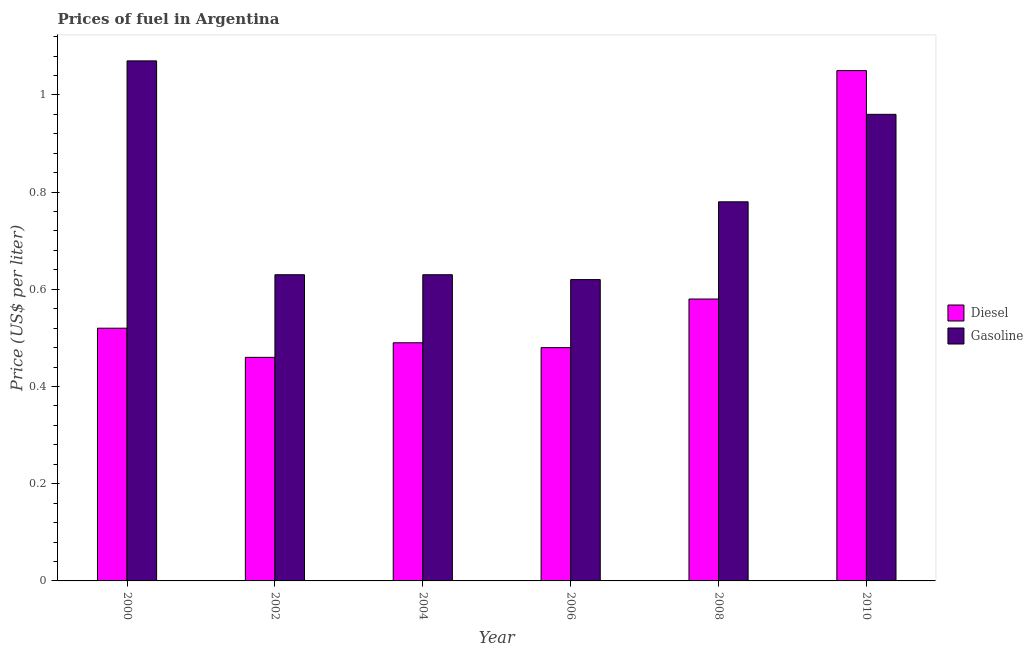How many different coloured bars are there?
Provide a succinct answer. 2. Are the number of bars per tick equal to the number of legend labels?
Your answer should be compact. Yes. How many bars are there on the 1st tick from the right?
Make the answer very short. 2. What is the label of the 1st group of bars from the left?
Provide a short and direct response. 2000. In how many cases, is the number of bars for a given year not equal to the number of legend labels?
Your answer should be compact. 0. What is the diesel price in 2006?
Make the answer very short. 0.48. Across all years, what is the maximum gasoline price?
Make the answer very short. 1.07. Across all years, what is the minimum diesel price?
Ensure brevity in your answer.  0.46. In which year was the gasoline price maximum?
Your answer should be very brief. 2000. What is the total gasoline price in the graph?
Your answer should be compact. 4.69. What is the difference between the gasoline price in 2006 and that in 2010?
Make the answer very short. -0.34. What is the difference between the gasoline price in 2008 and the diesel price in 2010?
Provide a short and direct response. -0.18. What is the average diesel price per year?
Give a very brief answer. 0.6. In the year 2002, what is the difference between the diesel price and gasoline price?
Your response must be concise. 0. What is the ratio of the diesel price in 2000 to that in 2006?
Give a very brief answer. 1.08. Is the difference between the diesel price in 2008 and 2010 greater than the difference between the gasoline price in 2008 and 2010?
Provide a succinct answer. No. What is the difference between the highest and the second highest diesel price?
Ensure brevity in your answer.  0.47. What is the difference between the highest and the lowest gasoline price?
Keep it short and to the point. 0.45. In how many years, is the diesel price greater than the average diesel price taken over all years?
Keep it short and to the point. 1. What does the 1st bar from the left in 2002 represents?
Ensure brevity in your answer.  Diesel. What does the 1st bar from the right in 2008 represents?
Make the answer very short. Gasoline. How many bars are there?
Offer a terse response. 12. Are all the bars in the graph horizontal?
Keep it short and to the point. No. What is the difference between two consecutive major ticks on the Y-axis?
Your response must be concise. 0.2. Are the values on the major ticks of Y-axis written in scientific E-notation?
Make the answer very short. No. Does the graph contain grids?
Provide a succinct answer. No. How many legend labels are there?
Give a very brief answer. 2. What is the title of the graph?
Keep it short and to the point. Prices of fuel in Argentina. Does "Enforce a contract" appear as one of the legend labels in the graph?
Your response must be concise. No. What is the label or title of the X-axis?
Your answer should be very brief. Year. What is the label or title of the Y-axis?
Your answer should be very brief. Price (US$ per liter). What is the Price (US$ per liter) of Diesel in 2000?
Make the answer very short. 0.52. What is the Price (US$ per liter) in Gasoline in 2000?
Your response must be concise. 1.07. What is the Price (US$ per liter) in Diesel in 2002?
Make the answer very short. 0.46. What is the Price (US$ per liter) in Gasoline in 2002?
Keep it short and to the point. 0.63. What is the Price (US$ per liter) in Diesel in 2004?
Ensure brevity in your answer.  0.49. What is the Price (US$ per liter) of Gasoline in 2004?
Your response must be concise. 0.63. What is the Price (US$ per liter) in Diesel in 2006?
Give a very brief answer. 0.48. What is the Price (US$ per liter) in Gasoline in 2006?
Keep it short and to the point. 0.62. What is the Price (US$ per liter) in Diesel in 2008?
Provide a short and direct response. 0.58. What is the Price (US$ per liter) in Gasoline in 2008?
Your answer should be compact. 0.78. Across all years, what is the maximum Price (US$ per liter) of Diesel?
Your answer should be very brief. 1.05. Across all years, what is the maximum Price (US$ per liter) of Gasoline?
Your answer should be compact. 1.07. Across all years, what is the minimum Price (US$ per liter) in Diesel?
Make the answer very short. 0.46. Across all years, what is the minimum Price (US$ per liter) of Gasoline?
Your response must be concise. 0.62. What is the total Price (US$ per liter) in Diesel in the graph?
Provide a succinct answer. 3.58. What is the total Price (US$ per liter) in Gasoline in the graph?
Offer a very short reply. 4.69. What is the difference between the Price (US$ per liter) of Diesel in 2000 and that in 2002?
Offer a terse response. 0.06. What is the difference between the Price (US$ per liter) in Gasoline in 2000 and that in 2002?
Offer a terse response. 0.44. What is the difference between the Price (US$ per liter) of Gasoline in 2000 and that in 2004?
Your answer should be compact. 0.44. What is the difference between the Price (US$ per liter) of Diesel in 2000 and that in 2006?
Keep it short and to the point. 0.04. What is the difference between the Price (US$ per liter) in Gasoline in 2000 and that in 2006?
Keep it short and to the point. 0.45. What is the difference between the Price (US$ per liter) of Diesel in 2000 and that in 2008?
Offer a terse response. -0.06. What is the difference between the Price (US$ per liter) of Gasoline in 2000 and that in 2008?
Keep it short and to the point. 0.29. What is the difference between the Price (US$ per liter) of Diesel in 2000 and that in 2010?
Provide a succinct answer. -0.53. What is the difference between the Price (US$ per liter) in Gasoline in 2000 and that in 2010?
Ensure brevity in your answer.  0.11. What is the difference between the Price (US$ per liter) of Diesel in 2002 and that in 2004?
Your answer should be very brief. -0.03. What is the difference between the Price (US$ per liter) of Diesel in 2002 and that in 2006?
Provide a short and direct response. -0.02. What is the difference between the Price (US$ per liter) in Diesel in 2002 and that in 2008?
Provide a succinct answer. -0.12. What is the difference between the Price (US$ per liter) in Gasoline in 2002 and that in 2008?
Offer a terse response. -0.15. What is the difference between the Price (US$ per liter) of Diesel in 2002 and that in 2010?
Offer a very short reply. -0.59. What is the difference between the Price (US$ per liter) in Gasoline in 2002 and that in 2010?
Ensure brevity in your answer.  -0.33. What is the difference between the Price (US$ per liter) of Gasoline in 2004 and that in 2006?
Give a very brief answer. 0.01. What is the difference between the Price (US$ per liter) in Diesel in 2004 and that in 2008?
Give a very brief answer. -0.09. What is the difference between the Price (US$ per liter) in Gasoline in 2004 and that in 2008?
Give a very brief answer. -0.15. What is the difference between the Price (US$ per liter) in Diesel in 2004 and that in 2010?
Ensure brevity in your answer.  -0.56. What is the difference between the Price (US$ per liter) of Gasoline in 2004 and that in 2010?
Make the answer very short. -0.33. What is the difference between the Price (US$ per liter) of Diesel in 2006 and that in 2008?
Your answer should be very brief. -0.1. What is the difference between the Price (US$ per liter) in Gasoline in 2006 and that in 2008?
Offer a terse response. -0.16. What is the difference between the Price (US$ per liter) in Diesel in 2006 and that in 2010?
Keep it short and to the point. -0.57. What is the difference between the Price (US$ per liter) in Gasoline in 2006 and that in 2010?
Offer a very short reply. -0.34. What is the difference between the Price (US$ per liter) of Diesel in 2008 and that in 2010?
Your answer should be compact. -0.47. What is the difference between the Price (US$ per liter) in Gasoline in 2008 and that in 2010?
Give a very brief answer. -0.18. What is the difference between the Price (US$ per liter) in Diesel in 2000 and the Price (US$ per liter) in Gasoline in 2002?
Keep it short and to the point. -0.11. What is the difference between the Price (US$ per liter) of Diesel in 2000 and the Price (US$ per liter) of Gasoline in 2004?
Keep it short and to the point. -0.11. What is the difference between the Price (US$ per liter) in Diesel in 2000 and the Price (US$ per liter) in Gasoline in 2008?
Your answer should be compact. -0.26. What is the difference between the Price (US$ per liter) in Diesel in 2000 and the Price (US$ per liter) in Gasoline in 2010?
Your answer should be very brief. -0.44. What is the difference between the Price (US$ per liter) in Diesel in 2002 and the Price (US$ per liter) in Gasoline in 2004?
Make the answer very short. -0.17. What is the difference between the Price (US$ per liter) in Diesel in 2002 and the Price (US$ per liter) in Gasoline in 2006?
Your answer should be compact. -0.16. What is the difference between the Price (US$ per liter) of Diesel in 2002 and the Price (US$ per liter) of Gasoline in 2008?
Your answer should be compact. -0.32. What is the difference between the Price (US$ per liter) of Diesel in 2002 and the Price (US$ per liter) of Gasoline in 2010?
Offer a terse response. -0.5. What is the difference between the Price (US$ per liter) in Diesel in 2004 and the Price (US$ per liter) in Gasoline in 2006?
Keep it short and to the point. -0.13. What is the difference between the Price (US$ per liter) in Diesel in 2004 and the Price (US$ per liter) in Gasoline in 2008?
Keep it short and to the point. -0.29. What is the difference between the Price (US$ per liter) of Diesel in 2004 and the Price (US$ per liter) of Gasoline in 2010?
Ensure brevity in your answer.  -0.47. What is the difference between the Price (US$ per liter) of Diesel in 2006 and the Price (US$ per liter) of Gasoline in 2010?
Your response must be concise. -0.48. What is the difference between the Price (US$ per liter) in Diesel in 2008 and the Price (US$ per liter) in Gasoline in 2010?
Offer a very short reply. -0.38. What is the average Price (US$ per liter) of Diesel per year?
Offer a terse response. 0.6. What is the average Price (US$ per liter) of Gasoline per year?
Make the answer very short. 0.78. In the year 2000, what is the difference between the Price (US$ per liter) of Diesel and Price (US$ per liter) of Gasoline?
Provide a succinct answer. -0.55. In the year 2002, what is the difference between the Price (US$ per liter) of Diesel and Price (US$ per liter) of Gasoline?
Your answer should be very brief. -0.17. In the year 2004, what is the difference between the Price (US$ per liter) in Diesel and Price (US$ per liter) in Gasoline?
Keep it short and to the point. -0.14. In the year 2006, what is the difference between the Price (US$ per liter) in Diesel and Price (US$ per liter) in Gasoline?
Offer a terse response. -0.14. In the year 2008, what is the difference between the Price (US$ per liter) of Diesel and Price (US$ per liter) of Gasoline?
Your answer should be very brief. -0.2. In the year 2010, what is the difference between the Price (US$ per liter) of Diesel and Price (US$ per liter) of Gasoline?
Keep it short and to the point. 0.09. What is the ratio of the Price (US$ per liter) of Diesel in 2000 to that in 2002?
Give a very brief answer. 1.13. What is the ratio of the Price (US$ per liter) of Gasoline in 2000 to that in 2002?
Your response must be concise. 1.7. What is the ratio of the Price (US$ per liter) of Diesel in 2000 to that in 2004?
Give a very brief answer. 1.06. What is the ratio of the Price (US$ per liter) of Gasoline in 2000 to that in 2004?
Ensure brevity in your answer.  1.7. What is the ratio of the Price (US$ per liter) of Diesel in 2000 to that in 2006?
Offer a terse response. 1.08. What is the ratio of the Price (US$ per liter) of Gasoline in 2000 to that in 2006?
Your response must be concise. 1.73. What is the ratio of the Price (US$ per liter) of Diesel in 2000 to that in 2008?
Your response must be concise. 0.9. What is the ratio of the Price (US$ per liter) in Gasoline in 2000 to that in 2008?
Your answer should be very brief. 1.37. What is the ratio of the Price (US$ per liter) in Diesel in 2000 to that in 2010?
Keep it short and to the point. 0.5. What is the ratio of the Price (US$ per liter) in Gasoline in 2000 to that in 2010?
Make the answer very short. 1.11. What is the ratio of the Price (US$ per liter) of Diesel in 2002 to that in 2004?
Offer a terse response. 0.94. What is the ratio of the Price (US$ per liter) of Diesel in 2002 to that in 2006?
Your response must be concise. 0.96. What is the ratio of the Price (US$ per liter) in Gasoline in 2002 to that in 2006?
Your answer should be compact. 1.02. What is the ratio of the Price (US$ per liter) of Diesel in 2002 to that in 2008?
Offer a very short reply. 0.79. What is the ratio of the Price (US$ per liter) of Gasoline in 2002 to that in 2008?
Provide a short and direct response. 0.81. What is the ratio of the Price (US$ per liter) of Diesel in 2002 to that in 2010?
Provide a short and direct response. 0.44. What is the ratio of the Price (US$ per liter) in Gasoline in 2002 to that in 2010?
Offer a terse response. 0.66. What is the ratio of the Price (US$ per liter) in Diesel in 2004 to that in 2006?
Give a very brief answer. 1.02. What is the ratio of the Price (US$ per liter) of Gasoline in 2004 to that in 2006?
Your response must be concise. 1.02. What is the ratio of the Price (US$ per liter) in Diesel in 2004 to that in 2008?
Provide a short and direct response. 0.84. What is the ratio of the Price (US$ per liter) of Gasoline in 2004 to that in 2008?
Your answer should be compact. 0.81. What is the ratio of the Price (US$ per liter) in Diesel in 2004 to that in 2010?
Your response must be concise. 0.47. What is the ratio of the Price (US$ per liter) in Gasoline in 2004 to that in 2010?
Ensure brevity in your answer.  0.66. What is the ratio of the Price (US$ per liter) of Diesel in 2006 to that in 2008?
Provide a succinct answer. 0.83. What is the ratio of the Price (US$ per liter) of Gasoline in 2006 to that in 2008?
Keep it short and to the point. 0.79. What is the ratio of the Price (US$ per liter) of Diesel in 2006 to that in 2010?
Keep it short and to the point. 0.46. What is the ratio of the Price (US$ per liter) of Gasoline in 2006 to that in 2010?
Your answer should be very brief. 0.65. What is the ratio of the Price (US$ per liter) of Diesel in 2008 to that in 2010?
Offer a terse response. 0.55. What is the ratio of the Price (US$ per liter) in Gasoline in 2008 to that in 2010?
Offer a terse response. 0.81. What is the difference between the highest and the second highest Price (US$ per liter) of Diesel?
Your response must be concise. 0.47. What is the difference between the highest and the second highest Price (US$ per liter) of Gasoline?
Your answer should be compact. 0.11. What is the difference between the highest and the lowest Price (US$ per liter) in Diesel?
Give a very brief answer. 0.59. What is the difference between the highest and the lowest Price (US$ per liter) of Gasoline?
Offer a very short reply. 0.45. 